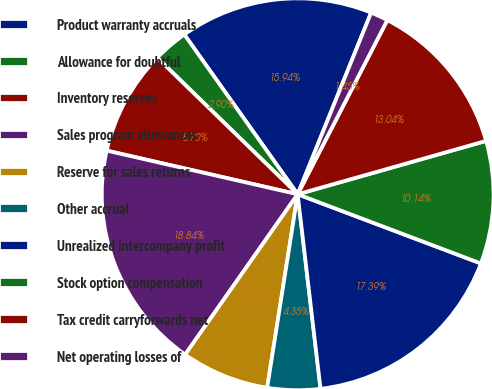<chart> <loc_0><loc_0><loc_500><loc_500><pie_chart><fcel>Product warranty accruals<fcel>Allowance for doubtful<fcel>Inventory reserves<fcel>Sales program allowances<fcel>Reserve for sales returns<fcel>Other accrual<fcel>Unrealized intercompany profit<fcel>Stock option compensation<fcel>Tax credit carryforwards net<fcel>Net operating losses of<nl><fcel>15.94%<fcel>2.9%<fcel>8.7%<fcel>18.84%<fcel>7.25%<fcel>4.35%<fcel>17.39%<fcel>10.14%<fcel>13.04%<fcel>1.45%<nl></chart> 